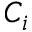Convert formula to latex. <formula><loc_0><loc_0><loc_500><loc_500>C _ { i }</formula> 